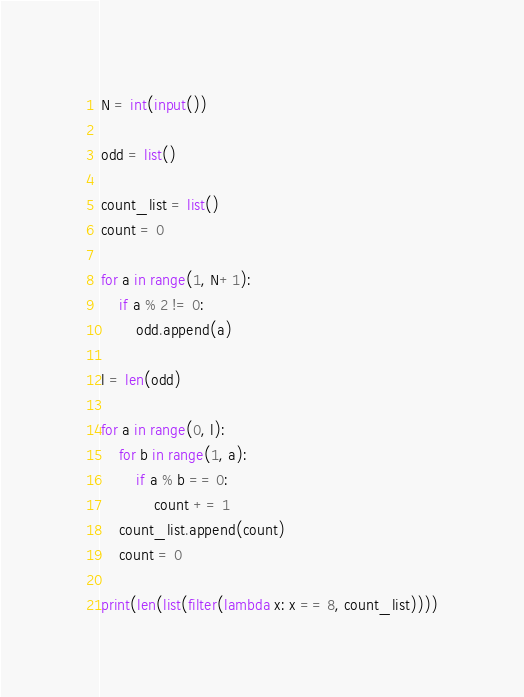<code> <loc_0><loc_0><loc_500><loc_500><_Python_>N = int(input())

odd = list()

count_list = list()
count = 0

for a in range(1, N+1):
    if a % 2 != 0:
        odd.append(a)

l = len(odd)

for a in range(0, l):
    for b in range(1, a):
        if a % b == 0:
            count += 1
    count_list.append(count)
    count = 0

print(len(list(filter(lambda x: x == 8, count_list))))
</code> 